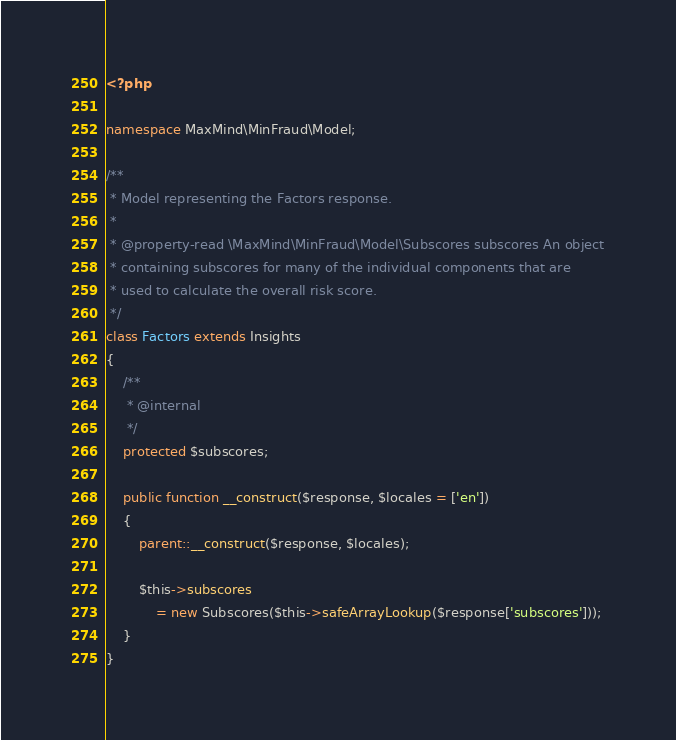<code> <loc_0><loc_0><loc_500><loc_500><_PHP_><?php

namespace MaxMind\MinFraud\Model;

/**
 * Model representing the Factors response.
 *
 * @property-read \MaxMind\MinFraud\Model\Subscores subscores An object
 * containing subscores for many of the individual components that are
 * used to calculate the overall risk score.
 */
class Factors extends Insights
{
    /**
     * @internal
     */
    protected $subscores;

    public function __construct($response, $locales = ['en'])
    {
        parent::__construct($response, $locales);

        $this->subscores
            = new Subscores($this->safeArrayLookup($response['subscores']));
    }
}
</code> 